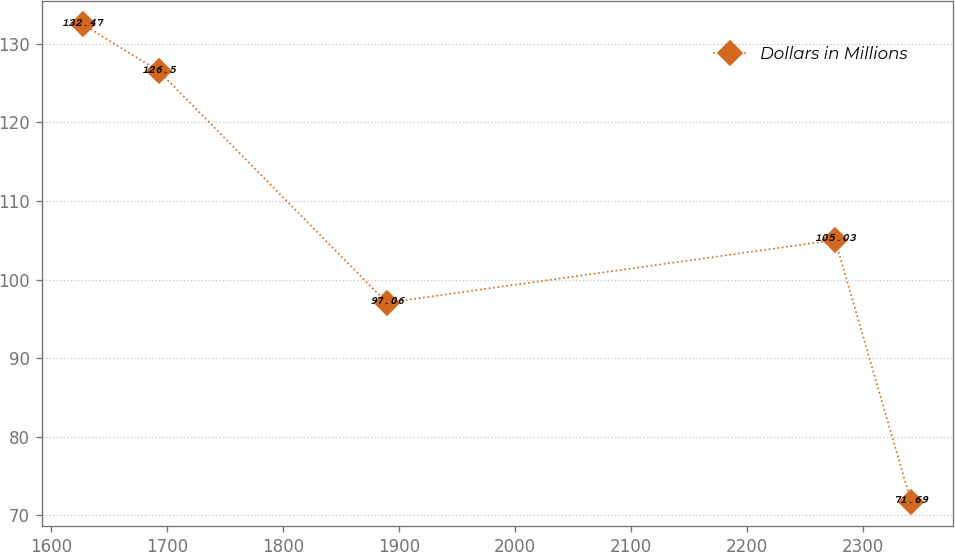Convert chart. <chart><loc_0><loc_0><loc_500><loc_500><line_chart><ecel><fcel>Dollars in Millions<nl><fcel>1627.88<fcel>132.47<nl><fcel>1693.33<fcel>126.5<nl><fcel>1889.52<fcel>97.06<nl><fcel>2275.86<fcel>105.03<nl><fcel>2341.31<fcel>71.69<nl></chart> 